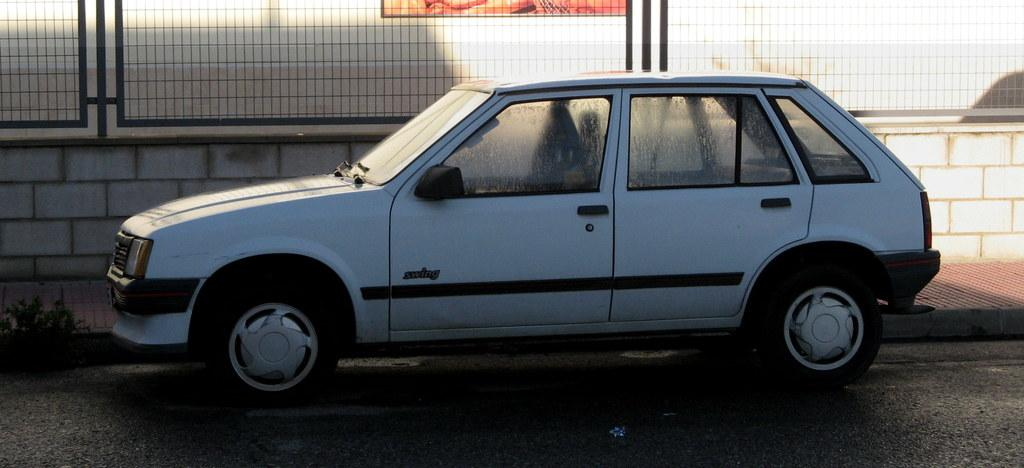What is the main subject of the image? The main subject of the image is a car. Can you describe the car's appearance? The car is white in color. Where is the car located in the image? The car is parked on the road. What can be seen in the background of the image? There is a wall, a footpath, and fencing in the background of the image. How many jellyfish are swimming in the car's engine in the image? There are no jellyfish present in the image, and they cannot swim in a car's engine. Is there a boy playing with a toy car in the image? There is no boy or toy car present in the image; it features a white car parked on the road. 